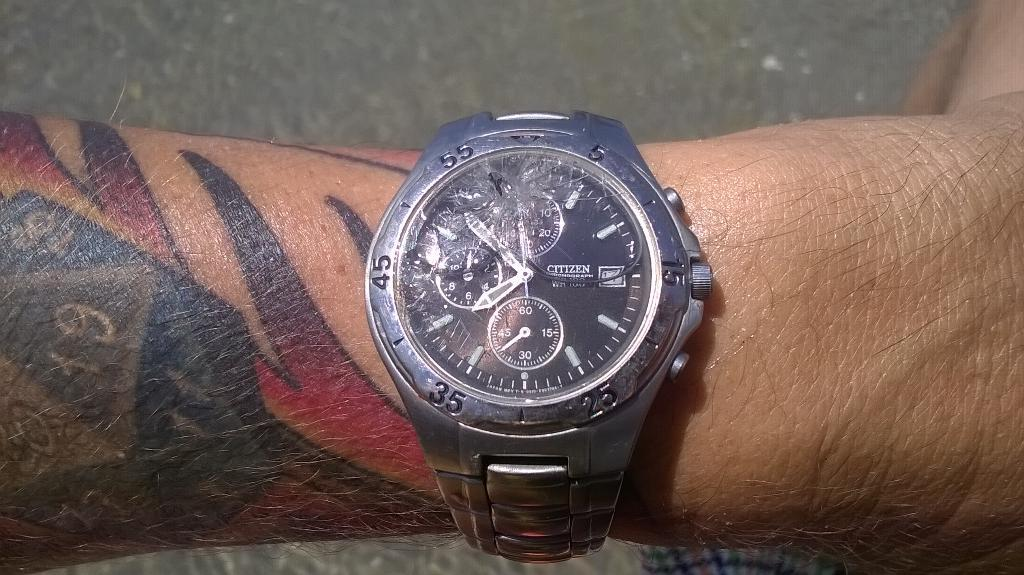<image>
Write a terse but informative summary of the picture. A tattooed man wears a Citizen watch on his wrist. 